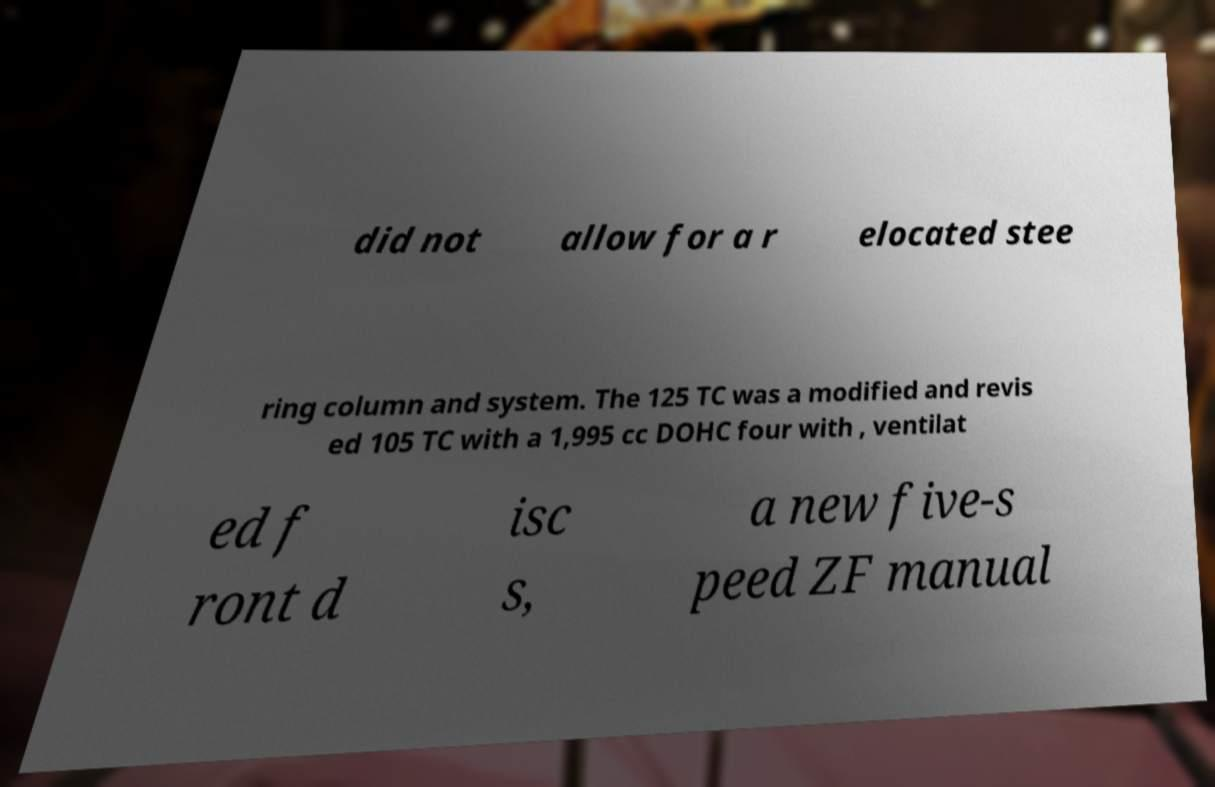Please identify and transcribe the text found in this image. did not allow for a r elocated stee ring column and system. The 125 TC was a modified and revis ed 105 TC with a 1,995 cc DOHC four with , ventilat ed f ront d isc s, a new five-s peed ZF manual 